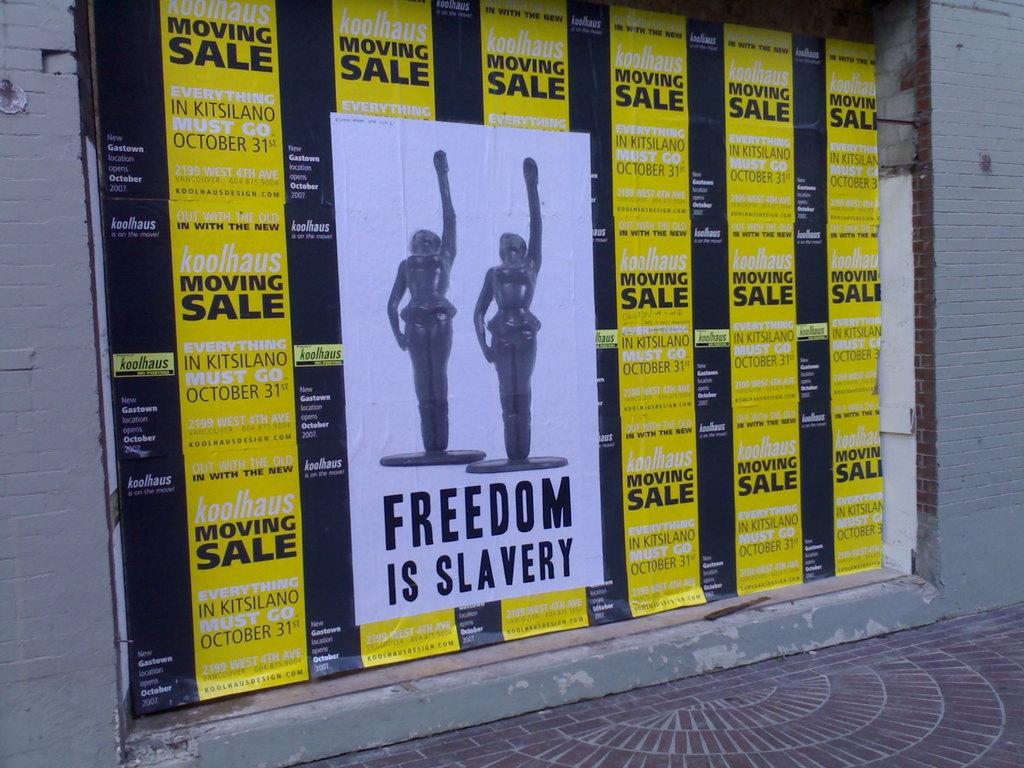<image>
Present a compact description of the photo's key features. Posters on a wall that say Freedom is Slavery. 